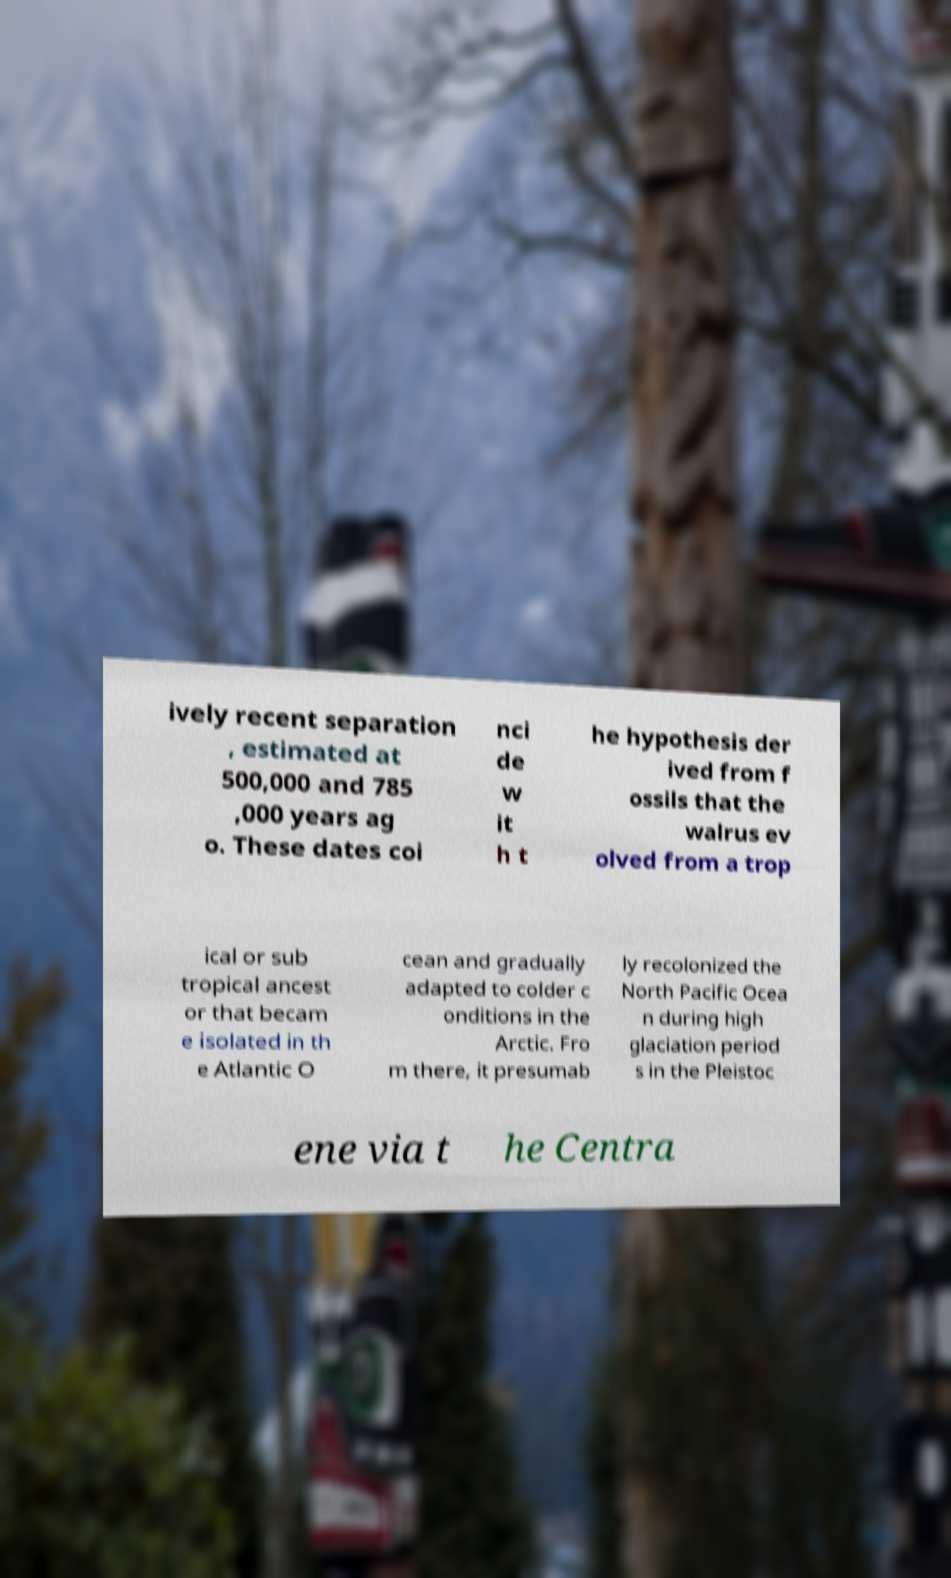For documentation purposes, I need the text within this image transcribed. Could you provide that? ively recent separation , estimated at 500,000 and 785 ,000 years ag o. These dates coi nci de w it h t he hypothesis der ived from f ossils that the walrus ev olved from a trop ical or sub tropical ancest or that becam e isolated in th e Atlantic O cean and gradually adapted to colder c onditions in the Arctic. Fro m there, it presumab ly recolonized the North Pacific Ocea n during high glaciation period s in the Pleistoc ene via t he Centra 